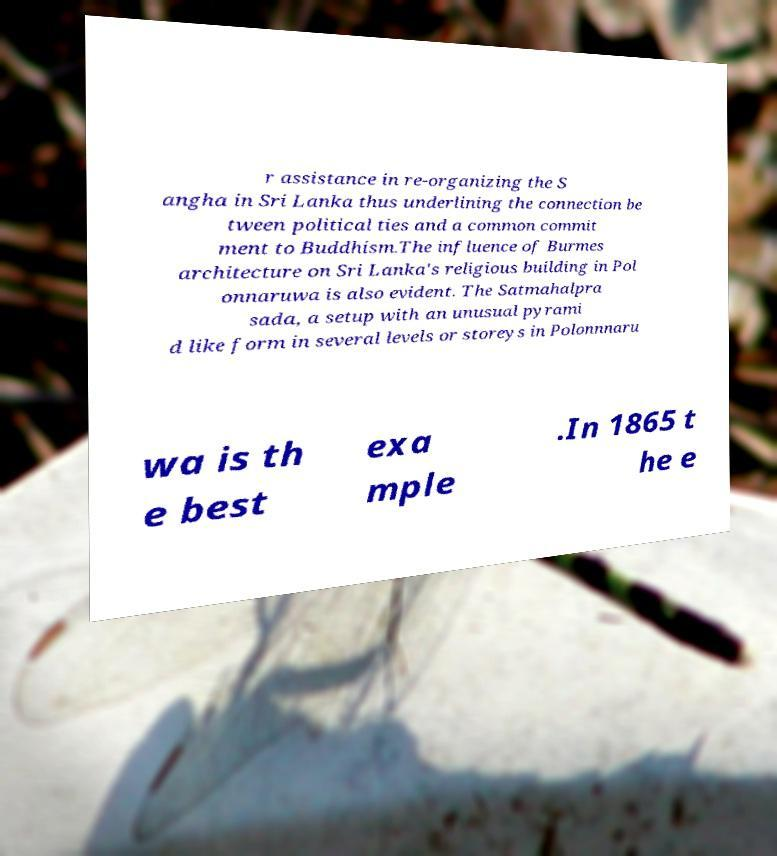I need the written content from this picture converted into text. Can you do that? r assistance in re-organizing the S angha in Sri Lanka thus underlining the connection be tween political ties and a common commit ment to Buddhism.The influence of Burmes architecture on Sri Lanka's religious building in Pol onnaruwa is also evident. The Satmahalpra sada, a setup with an unusual pyrami d like form in several levels or storeys in Polonnnaru wa is th e best exa mple .In 1865 t he e 